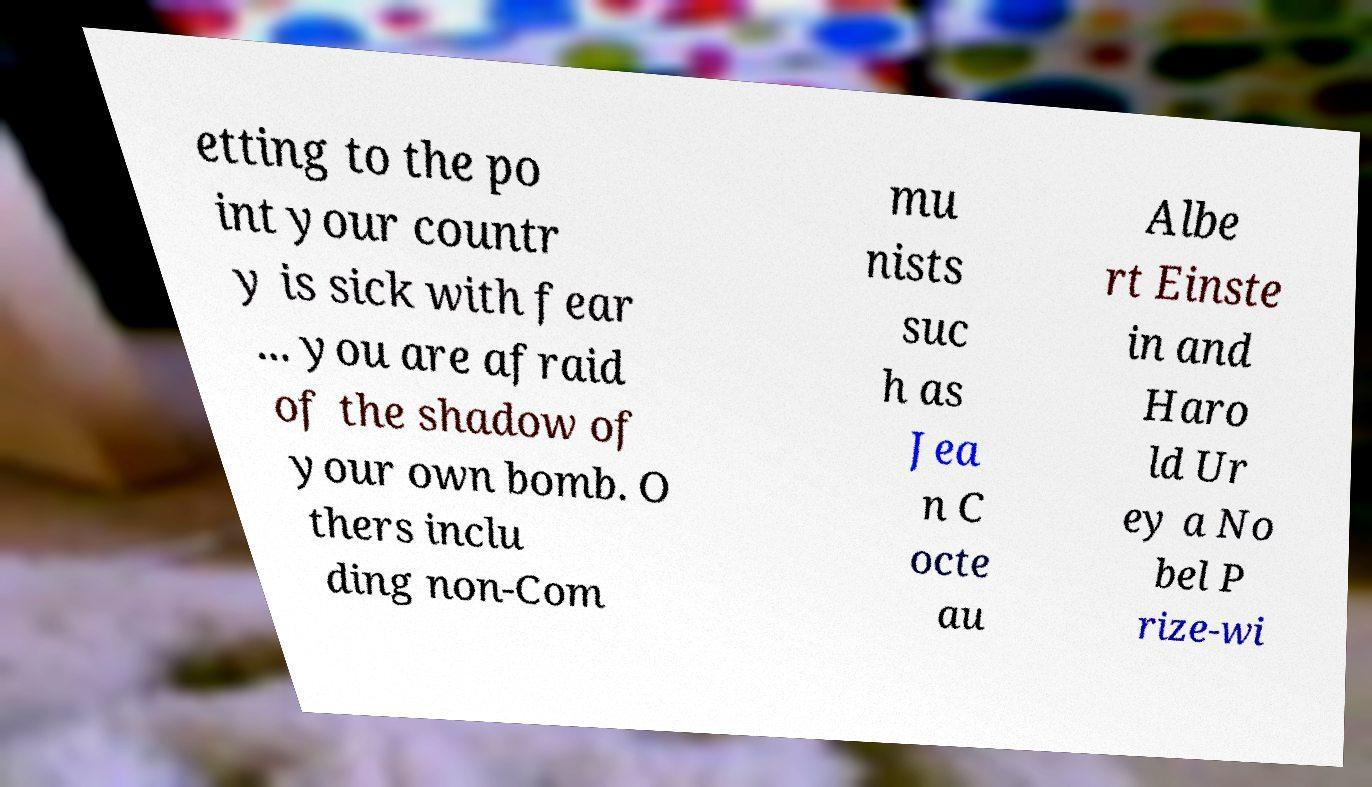I need the written content from this picture converted into text. Can you do that? etting to the po int your countr y is sick with fear ... you are afraid of the shadow of your own bomb. O thers inclu ding non-Com mu nists suc h as Jea n C octe au Albe rt Einste in and Haro ld Ur ey a No bel P rize-wi 